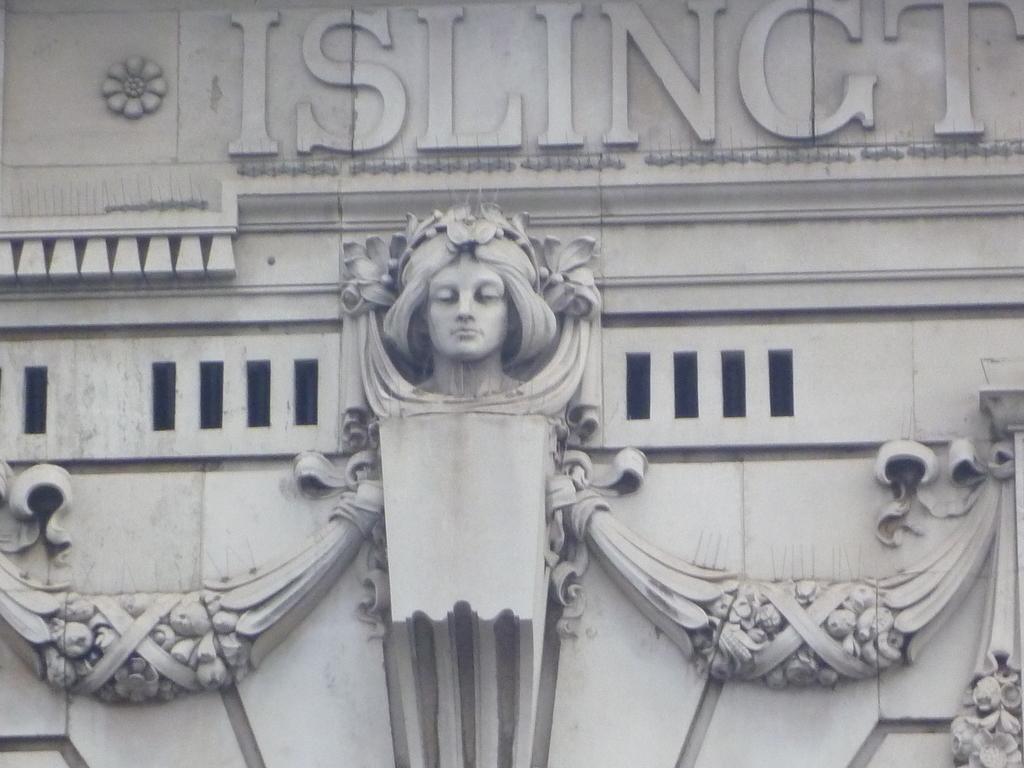Can you describe this image briefly? In this picture I can see a sculpture and letters on the wall. 